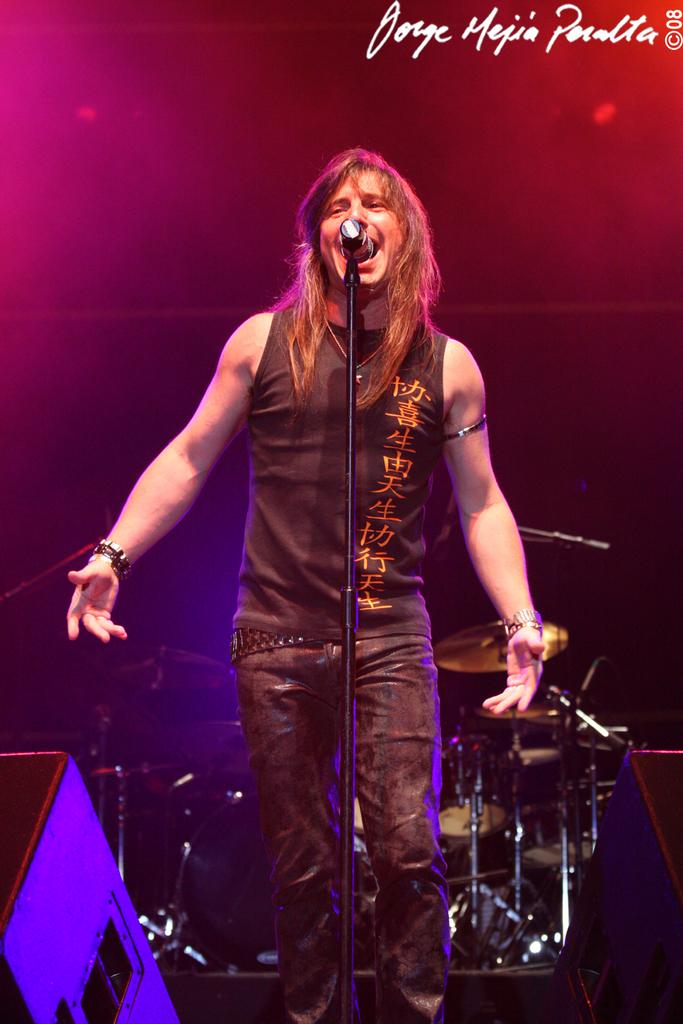What is the person in the image doing? The person is standing and singing into a microphone. What might be the purpose of the microphone in the image? The microphone is likely being used to amplify the person's voice while singing. What can be seen in the background of the image? There are musical instruments in the background of the image. What hand-held appliance is the person using to navigate their route in the image? There is no hand-held appliance or route mentioned in the image; the person is singing into a microphone. 